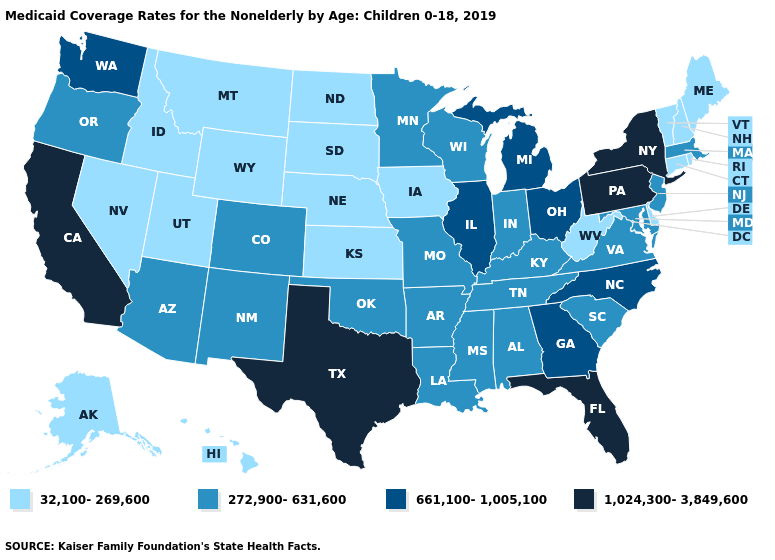Is the legend a continuous bar?
Answer briefly. No. What is the value of Maryland?
Short answer required. 272,900-631,600. Does Maryland have the lowest value in the USA?
Answer briefly. No. Name the states that have a value in the range 1,024,300-3,849,600?
Write a very short answer. California, Florida, New York, Pennsylvania, Texas. What is the lowest value in the MidWest?
Be succinct. 32,100-269,600. What is the value of New Hampshire?
Answer briefly. 32,100-269,600. Does the map have missing data?
Be succinct. No. Does California have the highest value in the West?
Answer briefly. Yes. Name the states that have a value in the range 32,100-269,600?
Give a very brief answer. Alaska, Connecticut, Delaware, Hawaii, Idaho, Iowa, Kansas, Maine, Montana, Nebraska, Nevada, New Hampshire, North Dakota, Rhode Island, South Dakota, Utah, Vermont, West Virginia, Wyoming. Name the states that have a value in the range 661,100-1,005,100?
Keep it brief. Georgia, Illinois, Michigan, North Carolina, Ohio, Washington. Name the states that have a value in the range 272,900-631,600?
Concise answer only. Alabama, Arizona, Arkansas, Colorado, Indiana, Kentucky, Louisiana, Maryland, Massachusetts, Minnesota, Mississippi, Missouri, New Jersey, New Mexico, Oklahoma, Oregon, South Carolina, Tennessee, Virginia, Wisconsin. Does California have the highest value in the West?
Give a very brief answer. Yes. Is the legend a continuous bar?
Write a very short answer. No. What is the lowest value in the West?
Keep it brief. 32,100-269,600. Does New Hampshire have a higher value than Texas?
Quick response, please. No. 